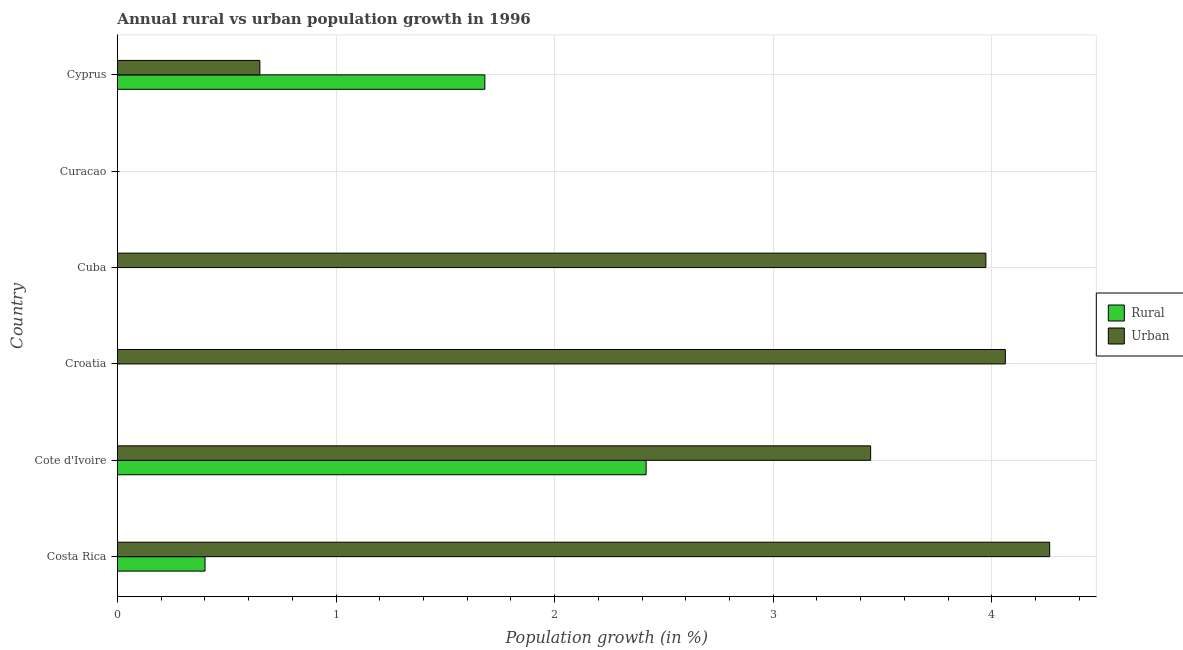How many different coloured bars are there?
Ensure brevity in your answer.  2. How many bars are there on the 2nd tick from the top?
Make the answer very short. 0. How many bars are there on the 5th tick from the bottom?
Your answer should be compact. 0. What is the urban population growth in Costa Rica?
Provide a short and direct response. 4.26. Across all countries, what is the maximum rural population growth?
Offer a very short reply. 2.42. In which country was the rural population growth maximum?
Your answer should be very brief. Cote d'Ivoire. What is the total urban population growth in the graph?
Offer a terse response. 16.4. What is the difference between the urban population growth in Cote d'Ivoire and that in Cyprus?
Your response must be concise. 2.79. What is the difference between the urban population growth in Cyprus and the rural population growth in Curacao?
Your response must be concise. 0.65. What is the difference between the rural population growth and urban population growth in Costa Rica?
Your answer should be very brief. -3.86. What is the ratio of the urban population growth in Cuba to that in Cyprus?
Provide a short and direct response. 6.1. Is the rural population growth in Costa Rica less than that in Cyprus?
Offer a very short reply. Yes. Is the difference between the urban population growth in Cote d'Ivoire and Cyprus greater than the difference between the rural population growth in Cote d'Ivoire and Cyprus?
Your answer should be compact. Yes. What is the difference between the highest and the second highest rural population growth?
Make the answer very short. 0.74. What is the difference between the highest and the lowest rural population growth?
Your answer should be compact. 2.42. How many bars are there?
Your response must be concise. 8. How many countries are there in the graph?
Your answer should be compact. 6. Are the values on the major ticks of X-axis written in scientific E-notation?
Provide a short and direct response. No. Where does the legend appear in the graph?
Make the answer very short. Center right. How many legend labels are there?
Your answer should be compact. 2. How are the legend labels stacked?
Keep it short and to the point. Vertical. What is the title of the graph?
Provide a short and direct response. Annual rural vs urban population growth in 1996. What is the label or title of the X-axis?
Provide a succinct answer. Population growth (in %). What is the Population growth (in %) in Rural in Costa Rica?
Offer a terse response. 0.4. What is the Population growth (in %) in Urban  in Costa Rica?
Your answer should be compact. 4.26. What is the Population growth (in %) in Rural in Cote d'Ivoire?
Provide a short and direct response. 2.42. What is the Population growth (in %) of Urban  in Cote d'Ivoire?
Offer a terse response. 3.45. What is the Population growth (in %) of Rural in Croatia?
Your answer should be compact. 0. What is the Population growth (in %) of Urban  in Croatia?
Keep it short and to the point. 4.06. What is the Population growth (in %) of Urban  in Cuba?
Your answer should be compact. 3.97. What is the Population growth (in %) of Rural in Cyprus?
Your answer should be very brief. 1.68. What is the Population growth (in %) in Urban  in Cyprus?
Offer a terse response. 0.65. Across all countries, what is the maximum Population growth (in %) in Rural?
Offer a terse response. 2.42. Across all countries, what is the maximum Population growth (in %) of Urban ?
Provide a short and direct response. 4.26. Across all countries, what is the minimum Population growth (in %) in Urban ?
Your response must be concise. 0. What is the total Population growth (in %) in Rural in the graph?
Your response must be concise. 4.5. What is the total Population growth (in %) in Urban  in the graph?
Your answer should be compact. 16.4. What is the difference between the Population growth (in %) in Rural in Costa Rica and that in Cote d'Ivoire?
Keep it short and to the point. -2.02. What is the difference between the Population growth (in %) in Urban  in Costa Rica and that in Cote d'Ivoire?
Your answer should be compact. 0.82. What is the difference between the Population growth (in %) of Urban  in Costa Rica and that in Croatia?
Provide a succinct answer. 0.2. What is the difference between the Population growth (in %) in Urban  in Costa Rica and that in Cuba?
Your response must be concise. 0.29. What is the difference between the Population growth (in %) in Rural in Costa Rica and that in Cyprus?
Give a very brief answer. -1.28. What is the difference between the Population growth (in %) in Urban  in Costa Rica and that in Cyprus?
Make the answer very short. 3.61. What is the difference between the Population growth (in %) in Urban  in Cote d'Ivoire and that in Croatia?
Make the answer very short. -0.62. What is the difference between the Population growth (in %) of Urban  in Cote d'Ivoire and that in Cuba?
Offer a terse response. -0.53. What is the difference between the Population growth (in %) of Rural in Cote d'Ivoire and that in Cyprus?
Give a very brief answer. 0.74. What is the difference between the Population growth (in %) in Urban  in Cote d'Ivoire and that in Cyprus?
Your answer should be compact. 2.79. What is the difference between the Population growth (in %) of Urban  in Croatia and that in Cuba?
Ensure brevity in your answer.  0.09. What is the difference between the Population growth (in %) in Urban  in Croatia and that in Cyprus?
Make the answer very short. 3.41. What is the difference between the Population growth (in %) of Urban  in Cuba and that in Cyprus?
Provide a succinct answer. 3.32. What is the difference between the Population growth (in %) in Rural in Costa Rica and the Population growth (in %) in Urban  in Cote d'Ivoire?
Your response must be concise. -3.04. What is the difference between the Population growth (in %) in Rural in Costa Rica and the Population growth (in %) in Urban  in Croatia?
Provide a succinct answer. -3.66. What is the difference between the Population growth (in %) of Rural in Costa Rica and the Population growth (in %) of Urban  in Cuba?
Offer a very short reply. -3.57. What is the difference between the Population growth (in %) of Rural in Costa Rica and the Population growth (in %) of Urban  in Cyprus?
Your answer should be very brief. -0.25. What is the difference between the Population growth (in %) in Rural in Cote d'Ivoire and the Population growth (in %) in Urban  in Croatia?
Make the answer very short. -1.64. What is the difference between the Population growth (in %) of Rural in Cote d'Ivoire and the Population growth (in %) of Urban  in Cuba?
Offer a terse response. -1.55. What is the difference between the Population growth (in %) of Rural in Cote d'Ivoire and the Population growth (in %) of Urban  in Cyprus?
Your response must be concise. 1.77. What is the average Population growth (in %) of Urban  per country?
Ensure brevity in your answer.  2.73. What is the difference between the Population growth (in %) of Rural and Population growth (in %) of Urban  in Costa Rica?
Give a very brief answer. -3.86. What is the difference between the Population growth (in %) of Rural and Population growth (in %) of Urban  in Cote d'Ivoire?
Your answer should be very brief. -1.03. What is the difference between the Population growth (in %) in Rural and Population growth (in %) in Urban  in Cyprus?
Your answer should be very brief. 1.03. What is the ratio of the Population growth (in %) of Rural in Costa Rica to that in Cote d'Ivoire?
Give a very brief answer. 0.17. What is the ratio of the Population growth (in %) in Urban  in Costa Rica to that in Cote d'Ivoire?
Provide a short and direct response. 1.24. What is the ratio of the Population growth (in %) of Urban  in Costa Rica to that in Croatia?
Give a very brief answer. 1.05. What is the ratio of the Population growth (in %) in Urban  in Costa Rica to that in Cuba?
Offer a very short reply. 1.07. What is the ratio of the Population growth (in %) of Rural in Costa Rica to that in Cyprus?
Your response must be concise. 0.24. What is the ratio of the Population growth (in %) in Urban  in Costa Rica to that in Cyprus?
Offer a very short reply. 6.54. What is the ratio of the Population growth (in %) in Urban  in Cote d'Ivoire to that in Croatia?
Make the answer very short. 0.85. What is the ratio of the Population growth (in %) in Urban  in Cote d'Ivoire to that in Cuba?
Ensure brevity in your answer.  0.87. What is the ratio of the Population growth (in %) of Rural in Cote d'Ivoire to that in Cyprus?
Make the answer very short. 1.44. What is the ratio of the Population growth (in %) of Urban  in Cote d'Ivoire to that in Cyprus?
Offer a very short reply. 5.29. What is the ratio of the Population growth (in %) of Urban  in Croatia to that in Cuba?
Provide a succinct answer. 1.02. What is the ratio of the Population growth (in %) in Urban  in Croatia to that in Cyprus?
Ensure brevity in your answer.  6.23. What is the ratio of the Population growth (in %) in Urban  in Cuba to that in Cyprus?
Provide a succinct answer. 6.1. What is the difference between the highest and the second highest Population growth (in %) of Rural?
Your answer should be compact. 0.74. What is the difference between the highest and the second highest Population growth (in %) in Urban ?
Provide a succinct answer. 0.2. What is the difference between the highest and the lowest Population growth (in %) of Rural?
Keep it short and to the point. 2.42. What is the difference between the highest and the lowest Population growth (in %) in Urban ?
Make the answer very short. 4.26. 